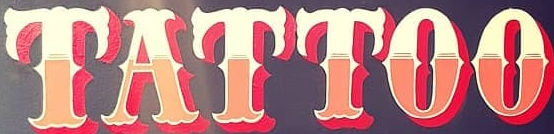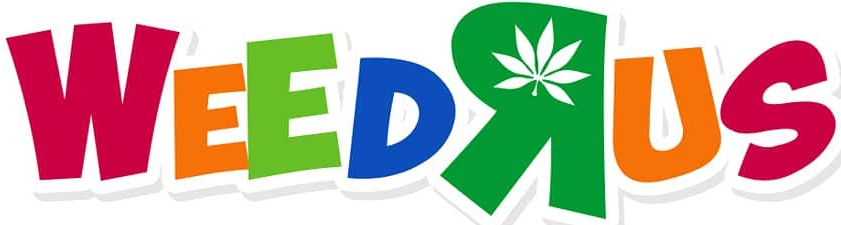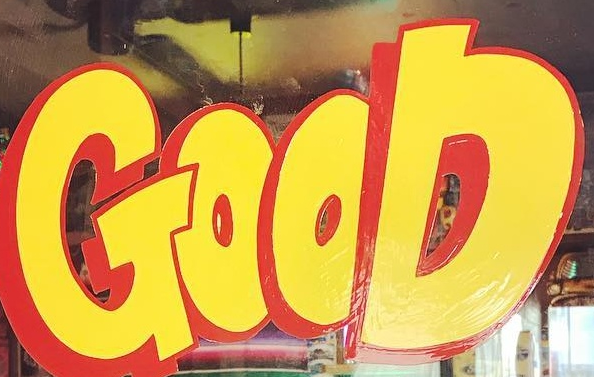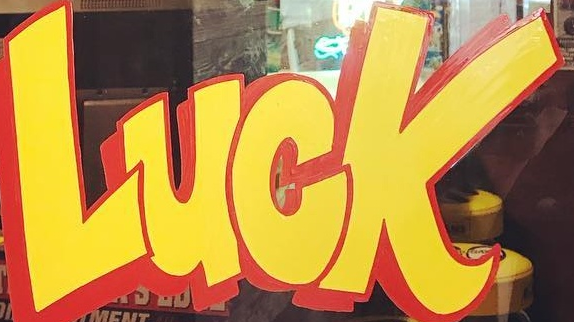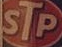Read the text content from these images in order, separated by a semicolon. TATTOO; WEEDRUS; GOOD; LUCK; STP 